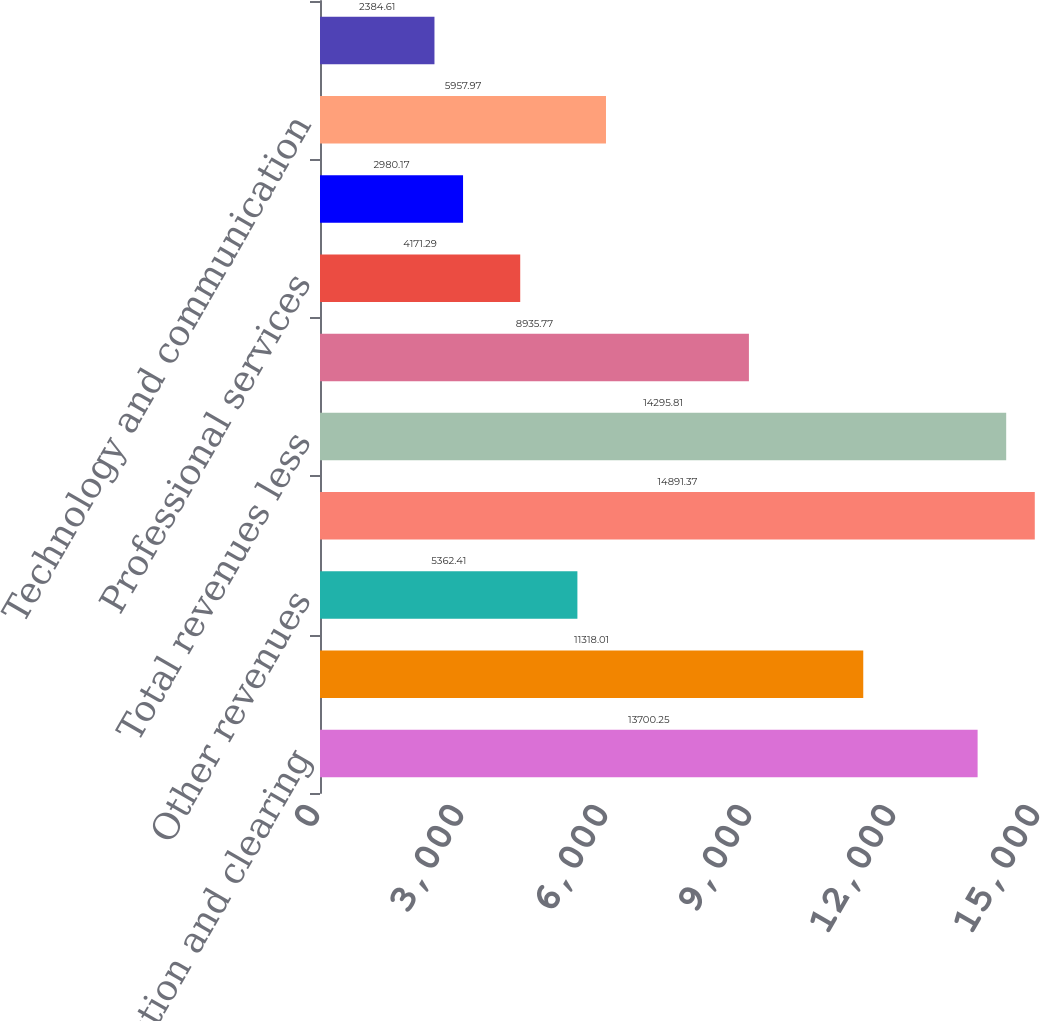Convert chart to OTSL. <chart><loc_0><loc_0><loc_500><loc_500><bar_chart><fcel>Transaction and clearing<fcel>Data services<fcel>Other revenues<fcel>Total revenues<fcel>Total revenues less<fcel>Compensation and benefits<fcel>Professional services<fcel>Acquisition-related<fcel>Technology and communication<fcel>Rent and occupancy<nl><fcel>13700.2<fcel>11318<fcel>5362.41<fcel>14891.4<fcel>14295.8<fcel>8935.77<fcel>4171.29<fcel>2980.17<fcel>5957.97<fcel>2384.61<nl></chart> 